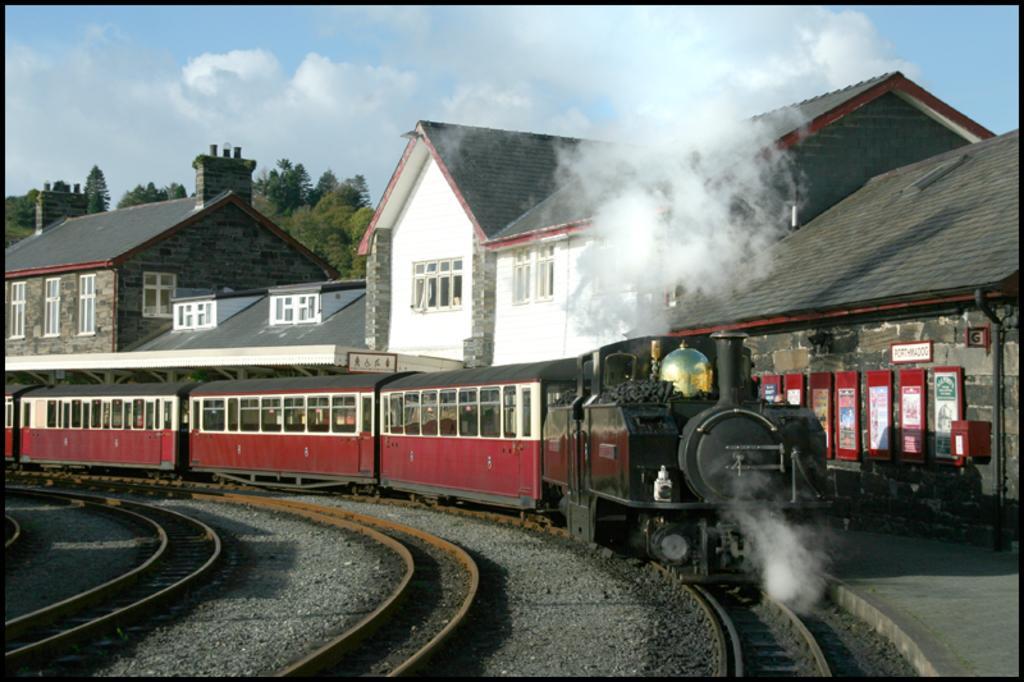How would you summarize this image in a sentence or two? There is a train moving on the railway track,beside the train there is a big compartment and in the front portion of the compartment there are many posters attached to a wall,behind the compartment there are a lot of trees. 